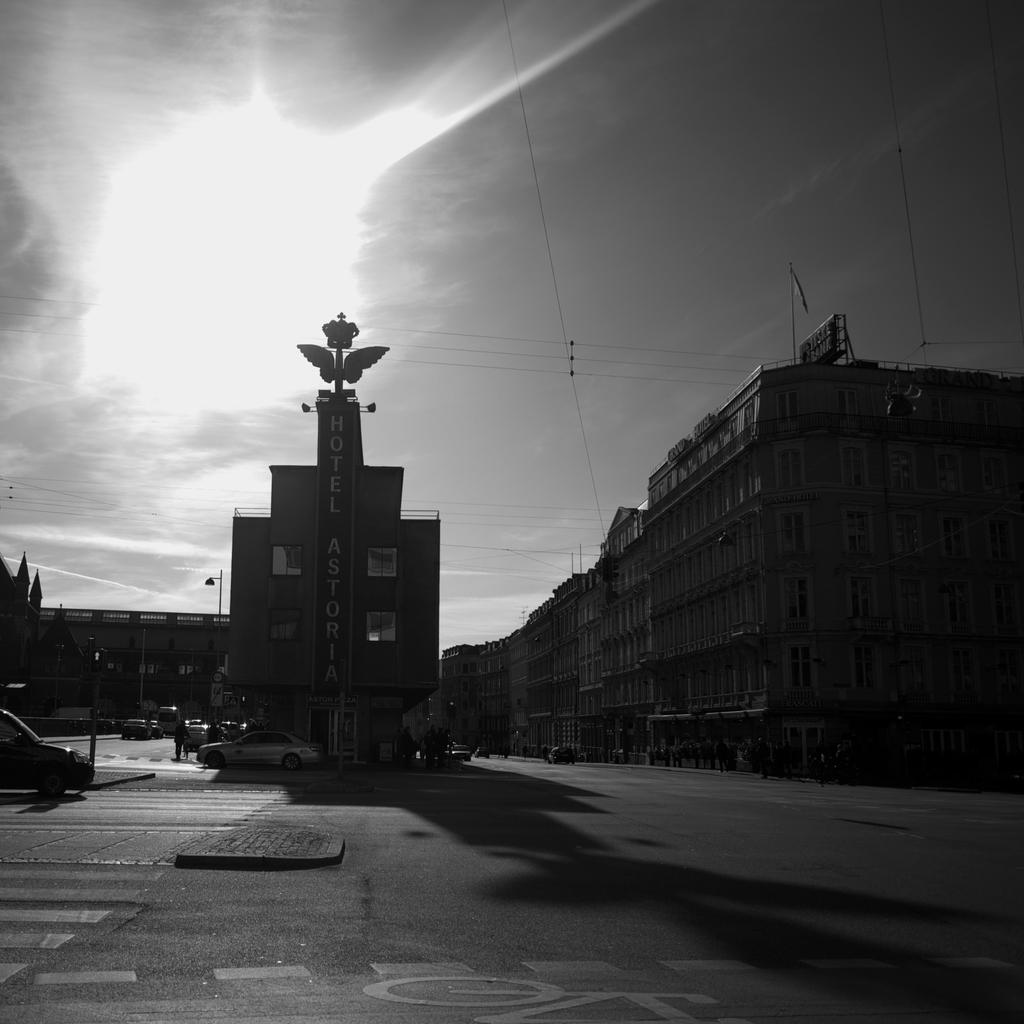What type of structures can be seen in the image? There are buildings in the image. What is happening on the road in the image? There are vehicles on the road in the image. What can be seen in the background of the image? The sun, sky, and wires are visible in the background of the image. What is the color scheme of the image? The image is black and white in color. What type of linen is being used for breakfast in the image? There is no linen or breakfast present in the image; it features buildings, vehicles, and a background with the sun, sky, and wires. What industry is depicted in the image? There is no specific industry depicted in the image; it shows a general urban scene with buildings, vehicles, and a background with the sun, sky, and wires. 